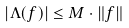Convert formula to latex. <formula><loc_0><loc_0><loc_500><loc_500>| \Lambda ( f ) | \leq M \cdot \| f \|</formula> 